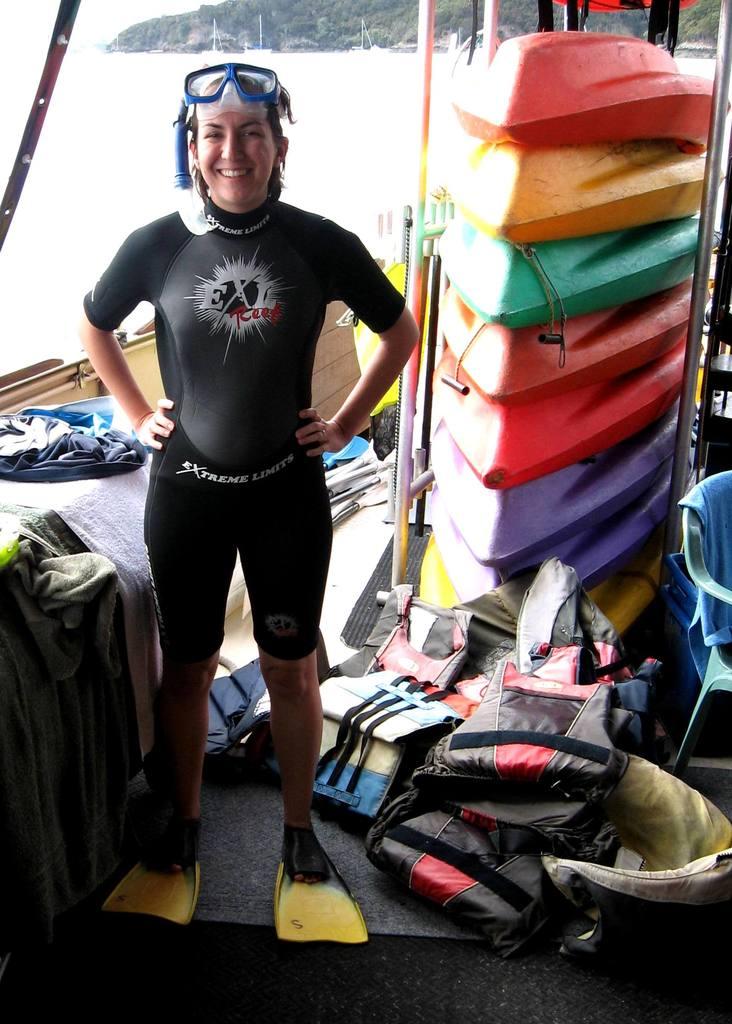What does her shirt say?
Offer a very short reply. Exl reef. 